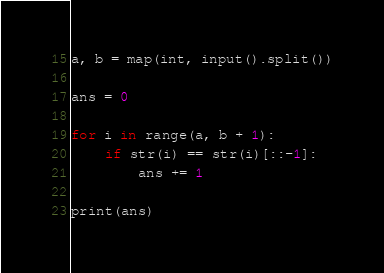Convert code to text. <code><loc_0><loc_0><loc_500><loc_500><_Python_>a, b = map(int, input().split())

ans = 0

for i in range(a, b + 1):
    if str(i) == str(i)[::-1]:
        ans += 1

print(ans)
</code> 